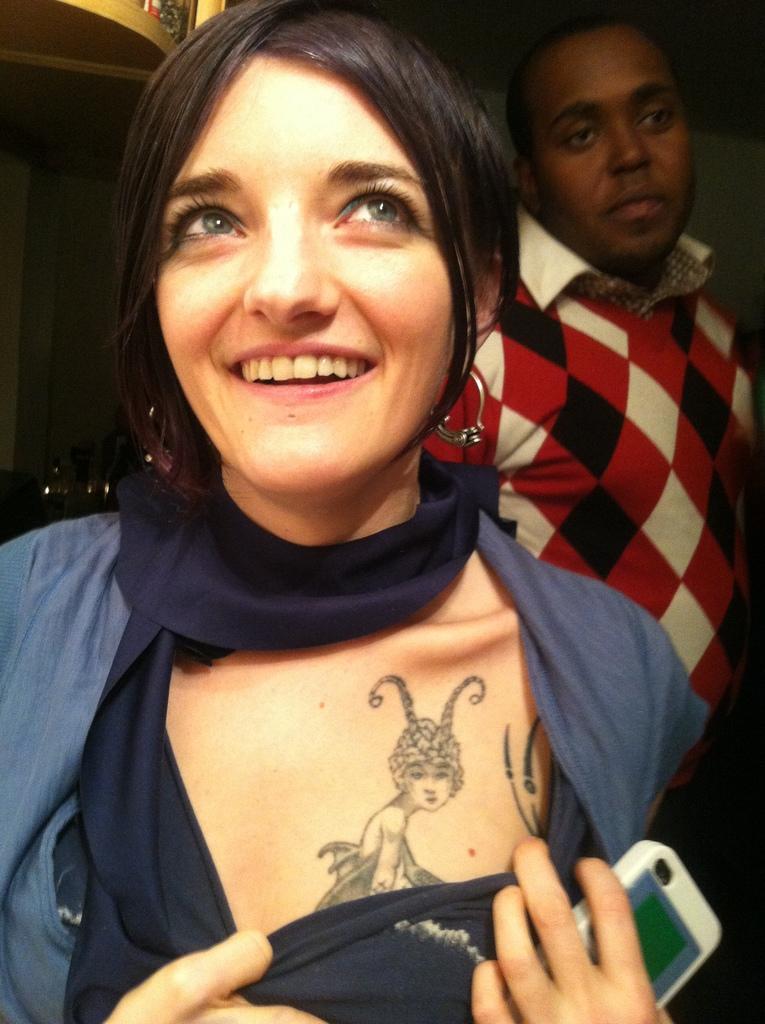Could you give a brief overview of what you see in this image? In this image I can see a woman is smiling and holding a mobile behind this woman I can see a man is standing. 